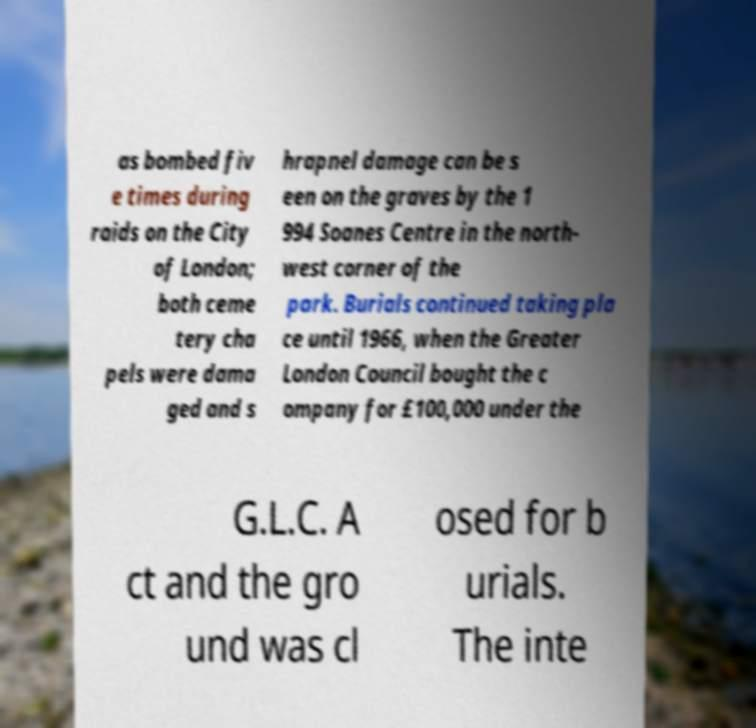Please identify and transcribe the text found in this image. as bombed fiv e times during raids on the City of London; both ceme tery cha pels were dama ged and s hrapnel damage can be s een on the graves by the 1 994 Soanes Centre in the north- west corner of the park. Burials continued taking pla ce until 1966, when the Greater London Council bought the c ompany for £100,000 under the G.L.C. A ct and the gro und was cl osed for b urials. The inte 